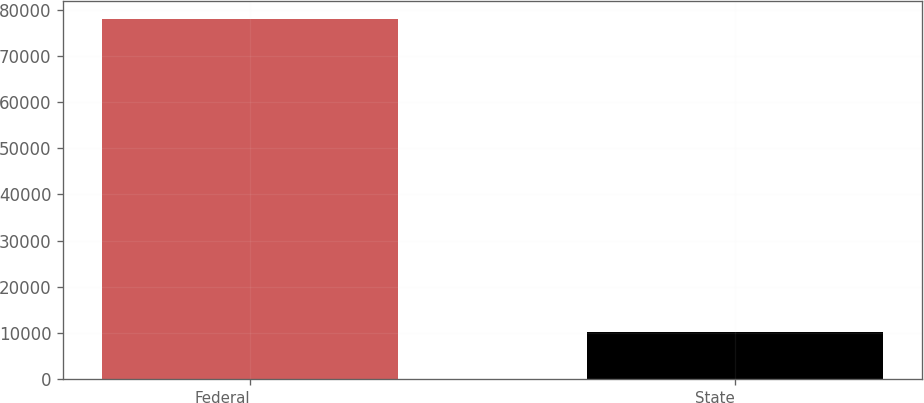Convert chart to OTSL. <chart><loc_0><loc_0><loc_500><loc_500><bar_chart><fcel>Federal<fcel>State<nl><fcel>77937<fcel>10166<nl></chart> 